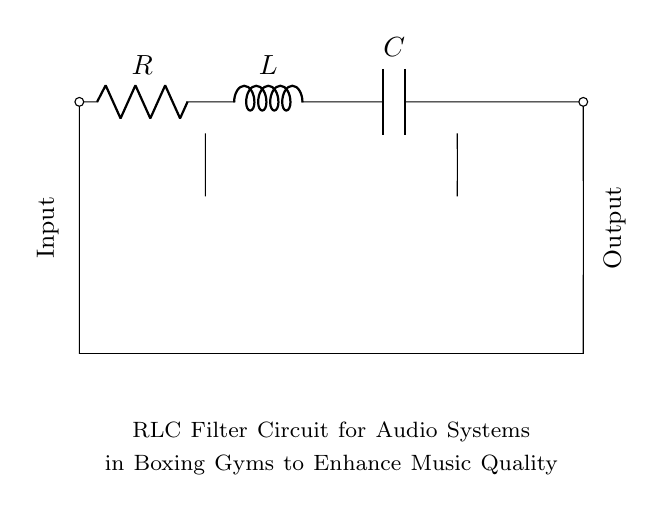What are the components in this circuit? The circuit contains a resistor, an inductor, and a capacitor, which are the fundamental components of an RLC circuit.
Answer: Resistor, Inductor, Capacitor What is the function of the resistor in this circuit? The resistor in the circuit limits the current flow, which helps control the signal level and affects the overall impedance of the circuit.
Answer: Current Limiting What is the purpose of the inductor in this circuit? The inductor stores energy in a magnetic field when current flows through it, which helps in filtering specific frequencies in the audio signal.
Answer: Energy Storage How does the capacitor affect the audio quality in this RLC circuit? The capacitor blocks direct current while allowing alternating current to pass through, which helps filter out unwanted frequencies, enhancing overall audio quality.
Answer: Frequency Filtering What is a key characteristic of RLC circuits in audio filtering? RLC circuits are known for their ability to create resonance at a specific frequency, allowing desired audio frequencies to pass while attenuating others.
Answer: Resonance 